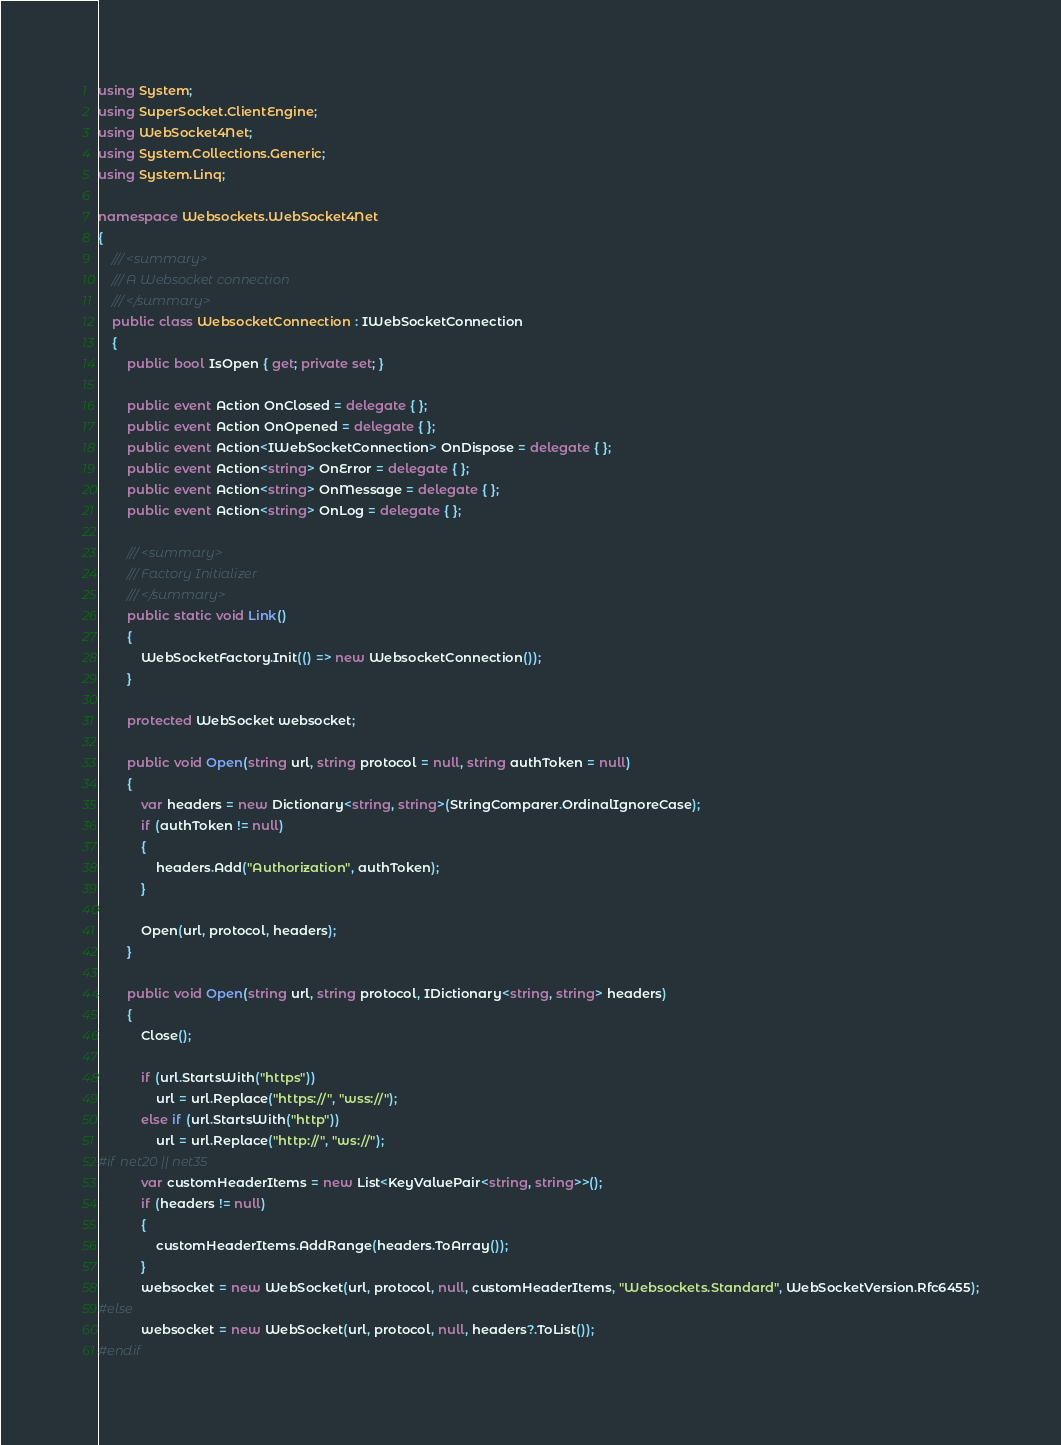<code> <loc_0><loc_0><loc_500><loc_500><_C#_>using System;
using SuperSocket.ClientEngine;
using WebSocket4Net;
using System.Collections.Generic;
using System.Linq;

namespace Websockets.WebSocket4Net
{
    /// <summary>
    /// A Websocket connection 
    /// </summary>
    public class WebsocketConnection : IWebSocketConnection
    {
        public bool IsOpen { get; private set; }

        public event Action OnClosed = delegate { };
        public event Action OnOpened = delegate { };
        public event Action<IWebSocketConnection> OnDispose = delegate { };
        public event Action<string> OnError = delegate { };
        public event Action<string> OnMessage = delegate { };
        public event Action<string> OnLog = delegate { };

        /// <summary>
        /// Factory Initializer
        /// </summary>
        public static void Link()
        {
            WebSocketFactory.Init(() => new WebsocketConnection());
        }

        protected WebSocket websocket;

        public void Open(string url, string protocol = null, string authToken = null)
        {
            var headers = new Dictionary<string, string>(StringComparer.OrdinalIgnoreCase);
            if (authToken != null)
            {
                headers.Add("Authorization", authToken);
            }

            Open(url, protocol, headers);
        }

        public void Open(string url, string protocol, IDictionary<string, string> headers)
        {
            Close();

            if (url.StartsWith("https"))
                url = url.Replace("https://", "wss://");
            else if (url.StartsWith("http"))
                url = url.Replace("http://", "ws://");
#if net20 || net35
            var customHeaderItems = new List<KeyValuePair<string, string>>();
            if (headers != null)
            {
                customHeaderItems.AddRange(headers.ToArray());
            }
            websocket = new WebSocket(url, protocol, null, customHeaderItems, "Websockets.Standard", WebSocketVersion.Rfc6455);
#else
            websocket = new WebSocket(url, protocol, null, headers?.ToList());
#endif</code> 